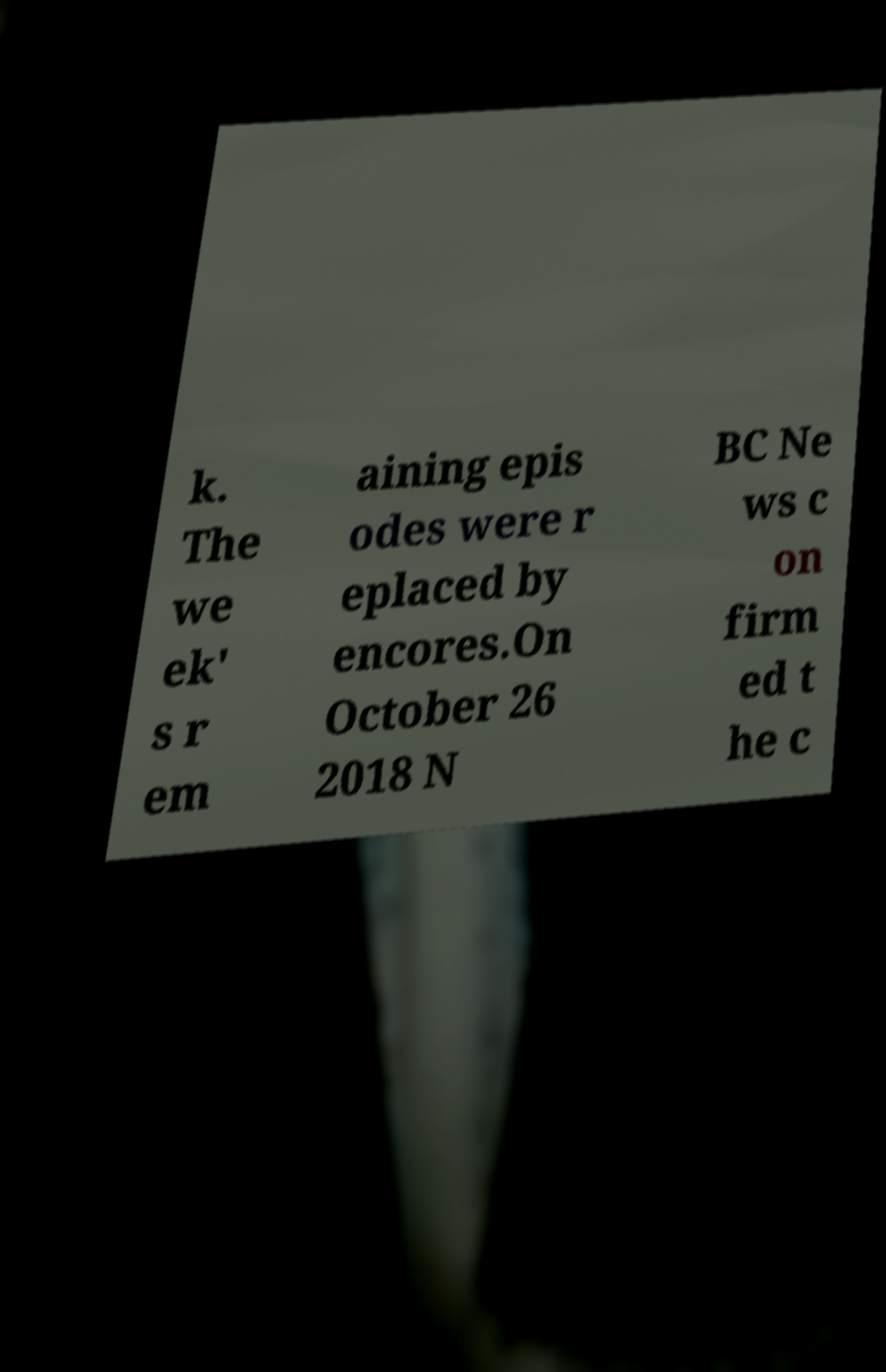There's text embedded in this image that I need extracted. Can you transcribe it verbatim? k. The we ek' s r em aining epis odes were r eplaced by encores.On October 26 2018 N BC Ne ws c on firm ed t he c 